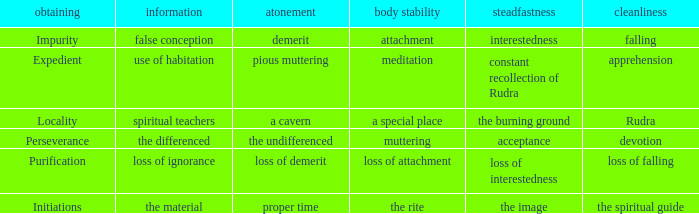 what's the permanence of the body where penance is the undifferenced Muttering. 